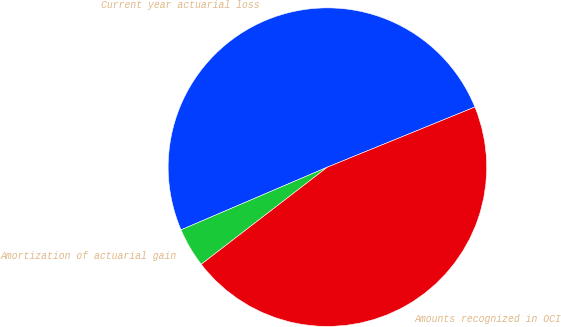Convert chart to OTSL. <chart><loc_0><loc_0><loc_500><loc_500><pie_chart><fcel>Current year actuarial loss<fcel>Amortization of actuarial gain<fcel>Amounts recognized in OCI<nl><fcel>50.28%<fcel>4.0%<fcel>45.71%<nl></chart> 